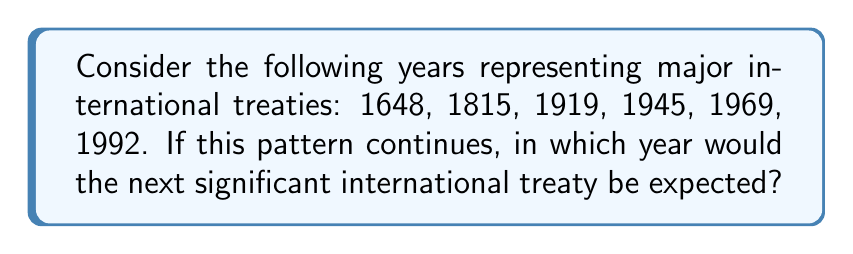Solve this math problem. To solve this problem, we need to analyze the pattern in the given sequence of years:

1. First, let's calculate the differences between consecutive years:
   1815 - 1648 = 167
   1919 - 1815 = 104
   1945 - 1919 = 26
   1969 - 1945 = 24
   1992 - 1969 = 23

2. We can observe that the differences are decreasing, but not in a linear fashion. Let's calculate the differences between these differences:
   167 - 104 = 63
   104 - 26 = 78
   26 - 24 = 2
   24 - 23 = 1

3. The pattern becomes clearer now. The difference between consecutive years is decreasing by approximately 1 each time:
   24 → 23 → 22 (predicted next difference)

4. Therefore, we can predict that the next difference will be 22 years.

5. To find the year of the next treaty, we add 22 to the last given year:
   1992 + 22 = 2014

Thus, based on the pattern, the next significant international treaty would be expected in 2014.
Answer: 2014 